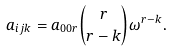Convert formula to latex. <formula><loc_0><loc_0><loc_500><loc_500>a _ { i j k } = a _ { 0 0 r } \binom { r } { r - k } \omega ^ { r - k } .</formula> 